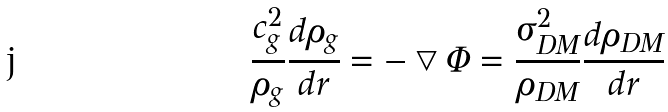<formula> <loc_0><loc_0><loc_500><loc_500>\frac { c _ { g } ^ { 2 } } { \rho _ { g } } \frac { d \rho _ { g } } { d r } = - \bigtriangledown \Phi = \frac { \sigma _ { D M } ^ { 2 } } { \rho _ { D M } } \frac { d \rho _ { D M } } { d r }</formula> 